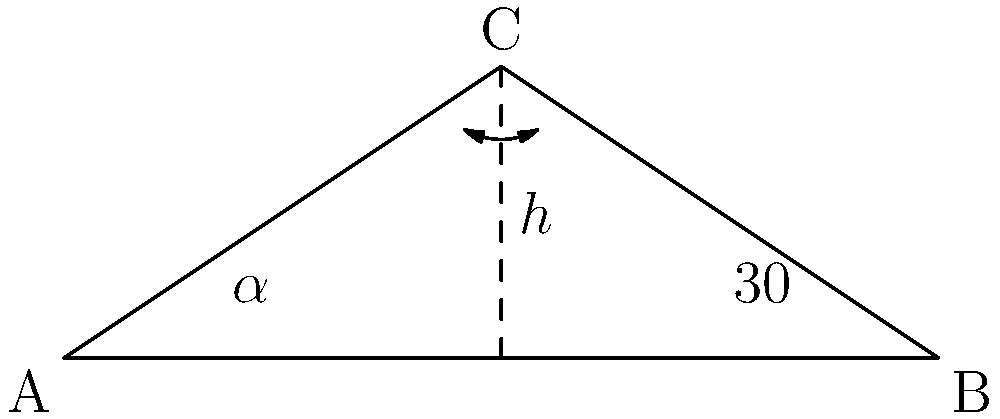A local solar panel installation company is designing a system for your zero-waste shop's roof. They propose a triangular arrangement where one side of the roof is at a 30° angle to the horizontal. If the height of the triangle is $h$ meters and the base is 6 meters wide, what should be the angle $\alpha$ of the other side to maximize energy efficiency? (Note: For maximum efficiency, the sum of the two angles should be 60°) Let's approach this step-by-step:

1) We know that one angle is 30°, and for maximum efficiency, the sum of the two angles should be 60°.

2) Therefore, the other angle $\alpha$ should be:
   $\alpha = 60° - 30° = 30°$

3) To verify this mathematically:
   
   a) In a right triangle, $\tan \theta = \frac{\text{opposite}}{\text{adjacent}}$
   
   b) For the known 30° angle: $\tan 30° = \frac{h}{3}$
   
   c) For the unknown angle $\alpha$: $\tan \alpha = \frac{h}{3}$
   
   d) Since these are equal, it confirms that $\alpha = 30°$

4) We can also calculate $h$ if needed:
   $h = 3 \tan 30° = 3 \cdot \frac{\sqrt{3}}{3} = \sqrt{3}$ meters

This arrangement ensures that both sides of the solar panel array receive equal sunlight throughout the day, maximizing energy efficiency for your zero-waste shop.
Answer: $30°$ 